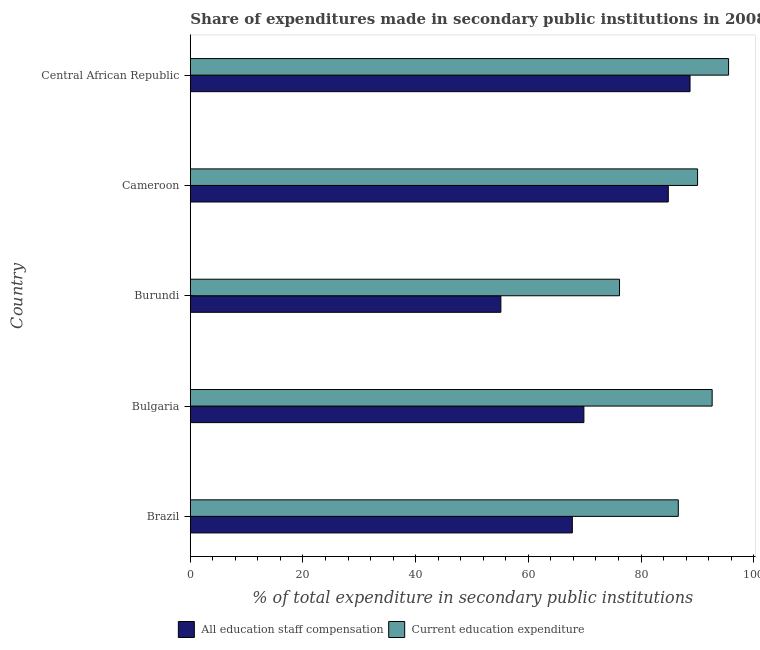How many groups of bars are there?
Your response must be concise. 5. Are the number of bars on each tick of the Y-axis equal?
Provide a succinct answer. Yes. What is the label of the 3rd group of bars from the top?
Your answer should be compact. Burundi. In how many cases, is the number of bars for a given country not equal to the number of legend labels?
Provide a short and direct response. 0. What is the expenditure in education in Cameroon?
Your response must be concise. 90.04. Across all countries, what is the maximum expenditure in staff compensation?
Provide a succinct answer. 88.7. Across all countries, what is the minimum expenditure in education?
Your answer should be very brief. 76.19. In which country was the expenditure in education maximum?
Make the answer very short. Central African Republic. In which country was the expenditure in education minimum?
Ensure brevity in your answer.  Burundi. What is the total expenditure in staff compensation in the graph?
Make the answer very short. 366.35. What is the difference between the expenditure in staff compensation in Brazil and that in Cameroon?
Your response must be concise. -17.03. What is the difference between the expenditure in education in Bulgaria and the expenditure in staff compensation in Central African Republic?
Provide a short and direct response. 3.93. What is the average expenditure in staff compensation per country?
Ensure brevity in your answer.  73.27. What is the difference between the expenditure in staff compensation and expenditure in education in Cameroon?
Offer a very short reply. -5.2. What is the ratio of the expenditure in education in Cameroon to that in Central African Republic?
Give a very brief answer. 0.94. Is the difference between the expenditure in education in Cameroon and Central African Republic greater than the difference between the expenditure in staff compensation in Cameroon and Central African Republic?
Keep it short and to the point. No. What is the difference between the highest and the second highest expenditure in staff compensation?
Keep it short and to the point. 3.86. What is the difference between the highest and the lowest expenditure in education?
Make the answer very short. 19.36. In how many countries, is the expenditure in education greater than the average expenditure in education taken over all countries?
Offer a very short reply. 3. What does the 1st bar from the top in Central African Republic represents?
Provide a short and direct response. Current education expenditure. What does the 1st bar from the bottom in Bulgaria represents?
Provide a succinct answer. All education staff compensation. How many bars are there?
Give a very brief answer. 10. Are all the bars in the graph horizontal?
Offer a terse response. Yes. How many countries are there in the graph?
Ensure brevity in your answer.  5. What is the difference between two consecutive major ticks on the X-axis?
Give a very brief answer. 20. Are the values on the major ticks of X-axis written in scientific E-notation?
Your answer should be very brief. No. Does the graph contain any zero values?
Ensure brevity in your answer.  No. How many legend labels are there?
Offer a terse response. 2. What is the title of the graph?
Ensure brevity in your answer.  Share of expenditures made in secondary public institutions in 2008. Does "Urban Population" appear as one of the legend labels in the graph?
Provide a short and direct response. No. What is the label or title of the X-axis?
Offer a very short reply. % of total expenditure in secondary public institutions. What is the label or title of the Y-axis?
Provide a short and direct response. Country. What is the % of total expenditure in secondary public institutions in All education staff compensation in Brazil?
Provide a succinct answer. 67.81. What is the % of total expenditure in secondary public institutions of Current education expenditure in Brazil?
Ensure brevity in your answer.  86.62. What is the % of total expenditure in secondary public institutions in All education staff compensation in Bulgaria?
Your response must be concise. 69.86. What is the % of total expenditure in secondary public institutions of Current education expenditure in Bulgaria?
Your answer should be very brief. 92.63. What is the % of total expenditure in secondary public institutions of All education staff compensation in Burundi?
Your response must be concise. 55.13. What is the % of total expenditure in secondary public institutions of Current education expenditure in Burundi?
Provide a short and direct response. 76.19. What is the % of total expenditure in secondary public institutions of All education staff compensation in Cameroon?
Your answer should be compact. 84.84. What is the % of total expenditure in secondary public institutions of Current education expenditure in Cameroon?
Make the answer very short. 90.04. What is the % of total expenditure in secondary public institutions in All education staff compensation in Central African Republic?
Make the answer very short. 88.7. What is the % of total expenditure in secondary public institutions in Current education expenditure in Central African Republic?
Offer a very short reply. 95.54. Across all countries, what is the maximum % of total expenditure in secondary public institutions of All education staff compensation?
Give a very brief answer. 88.7. Across all countries, what is the maximum % of total expenditure in secondary public institutions of Current education expenditure?
Your answer should be compact. 95.54. Across all countries, what is the minimum % of total expenditure in secondary public institutions of All education staff compensation?
Give a very brief answer. 55.13. Across all countries, what is the minimum % of total expenditure in secondary public institutions of Current education expenditure?
Make the answer very short. 76.19. What is the total % of total expenditure in secondary public institutions of All education staff compensation in the graph?
Ensure brevity in your answer.  366.35. What is the total % of total expenditure in secondary public institutions of Current education expenditure in the graph?
Offer a terse response. 441.03. What is the difference between the % of total expenditure in secondary public institutions in All education staff compensation in Brazil and that in Bulgaria?
Your response must be concise. -2.05. What is the difference between the % of total expenditure in secondary public institutions of Current education expenditure in Brazil and that in Bulgaria?
Provide a short and direct response. -6.01. What is the difference between the % of total expenditure in secondary public institutions in All education staff compensation in Brazil and that in Burundi?
Make the answer very short. 12.69. What is the difference between the % of total expenditure in secondary public institutions in Current education expenditure in Brazil and that in Burundi?
Provide a succinct answer. 10.43. What is the difference between the % of total expenditure in secondary public institutions in All education staff compensation in Brazil and that in Cameroon?
Provide a succinct answer. -17.03. What is the difference between the % of total expenditure in secondary public institutions in Current education expenditure in Brazil and that in Cameroon?
Keep it short and to the point. -3.42. What is the difference between the % of total expenditure in secondary public institutions in All education staff compensation in Brazil and that in Central African Republic?
Provide a succinct answer. -20.89. What is the difference between the % of total expenditure in secondary public institutions of Current education expenditure in Brazil and that in Central African Republic?
Keep it short and to the point. -8.93. What is the difference between the % of total expenditure in secondary public institutions in All education staff compensation in Bulgaria and that in Burundi?
Offer a terse response. 14.73. What is the difference between the % of total expenditure in secondary public institutions in Current education expenditure in Bulgaria and that in Burundi?
Provide a short and direct response. 16.44. What is the difference between the % of total expenditure in secondary public institutions in All education staff compensation in Bulgaria and that in Cameroon?
Your response must be concise. -14.98. What is the difference between the % of total expenditure in secondary public institutions in Current education expenditure in Bulgaria and that in Cameroon?
Your answer should be compact. 2.59. What is the difference between the % of total expenditure in secondary public institutions in All education staff compensation in Bulgaria and that in Central African Republic?
Provide a succinct answer. -18.84. What is the difference between the % of total expenditure in secondary public institutions of Current education expenditure in Bulgaria and that in Central African Republic?
Offer a terse response. -2.92. What is the difference between the % of total expenditure in secondary public institutions in All education staff compensation in Burundi and that in Cameroon?
Offer a terse response. -29.72. What is the difference between the % of total expenditure in secondary public institutions of Current education expenditure in Burundi and that in Cameroon?
Provide a short and direct response. -13.85. What is the difference between the % of total expenditure in secondary public institutions of All education staff compensation in Burundi and that in Central African Republic?
Give a very brief answer. -33.58. What is the difference between the % of total expenditure in secondary public institutions in Current education expenditure in Burundi and that in Central African Republic?
Provide a succinct answer. -19.36. What is the difference between the % of total expenditure in secondary public institutions of All education staff compensation in Cameroon and that in Central African Republic?
Ensure brevity in your answer.  -3.86. What is the difference between the % of total expenditure in secondary public institutions of Current education expenditure in Cameroon and that in Central African Republic?
Offer a very short reply. -5.5. What is the difference between the % of total expenditure in secondary public institutions of All education staff compensation in Brazil and the % of total expenditure in secondary public institutions of Current education expenditure in Bulgaria?
Offer a very short reply. -24.82. What is the difference between the % of total expenditure in secondary public institutions of All education staff compensation in Brazil and the % of total expenditure in secondary public institutions of Current education expenditure in Burundi?
Make the answer very short. -8.38. What is the difference between the % of total expenditure in secondary public institutions of All education staff compensation in Brazil and the % of total expenditure in secondary public institutions of Current education expenditure in Cameroon?
Provide a short and direct response. -22.23. What is the difference between the % of total expenditure in secondary public institutions in All education staff compensation in Brazil and the % of total expenditure in secondary public institutions in Current education expenditure in Central African Republic?
Your answer should be compact. -27.73. What is the difference between the % of total expenditure in secondary public institutions in All education staff compensation in Bulgaria and the % of total expenditure in secondary public institutions in Current education expenditure in Burundi?
Your answer should be very brief. -6.33. What is the difference between the % of total expenditure in secondary public institutions of All education staff compensation in Bulgaria and the % of total expenditure in secondary public institutions of Current education expenditure in Cameroon?
Give a very brief answer. -20.18. What is the difference between the % of total expenditure in secondary public institutions of All education staff compensation in Bulgaria and the % of total expenditure in secondary public institutions of Current education expenditure in Central African Republic?
Offer a terse response. -25.68. What is the difference between the % of total expenditure in secondary public institutions in All education staff compensation in Burundi and the % of total expenditure in secondary public institutions in Current education expenditure in Cameroon?
Your response must be concise. -34.91. What is the difference between the % of total expenditure in secondary public institutions of All education staff compensation in Burundi and the % of total expenditure in secondary public institutions of Current education expenditure in Central African Republic?
Provide a short and direct response. -40.42. What is the difference between the % of total expenditure in secondary public institutions in All education staff compensation in Cameroon and the % of total expenditure in secondary public institutions in Current education expenditure in Central African Republic?
Offer a terse response. -10.7. What is the average % of total expenditure in secondary public institutions in All education staff compensation per country?
Your answer should be very brief. 73.27. What is the average % of total expenditure in secondary public institutions of Current education expenditure per country?
Ensure brevity in your answer.  88.21. What is the difference between the % of total expenditure in secondary public institutions in All education staff compensation and % of total expenditure in secondary public institutions in Current education expenditure in Brazil?
Offer a terse response. -18.81. What is the difference between the % of total expenditure in secondary public institutions in All education staff compensation and % of total expenditure in secondary public institutions in Current education expenditure in Bulgaria?
Give a very brief answer. -22.77. What is the difference between the % of total expenditure in secondary public institutions in All education staff compensation and % of total expenditure in secondary public institutions in Current education expenditure in Burundi?
Your response must be concise. -21.06. What is the difference between the % of total expenditure in secondary public institutions in All education staff compensation and % of total expenditure in secondary public institutions in Current education expenditure in Cameroon?
Your answer should be very brief. -5.2. What is the difference between the % of total expenditure in secondary public institutions of All education staff compensation and % of total expenditure in secondary public institutions of Current education expenditure in Central African Republic?
Offer a terse response. -6.84. What is the ratio of the % of total expenditure in secondary public institutions of All education staff compensation in Brazil to that in Bulgaria?
Make the answer very short. 0.97. What is the ratio of the % of total expenditure in secondary public institutions of Current education expenditure in Brazil to that in Bulgaria?
Give a very brief answer. 0.94. What is the ratio of the % of total expenditure in secondary public institutions in All education staff compensation in Brazil to that in Burundi?
Keep it short and to the point. 1.23. What is the ratio of the % of total expenditure in secondary public institutions of Current education expenditure in Brazil to that in Burundi?
Keep it short and to the point. 1.14. What is the ratio of the % of total expenditure in secondary public institutions of All education staff compensation in Brazil to that in Cameroon?
Your answer should be compact. 0.8. What is the ratio of the % of total expenditure in secondary public institutions of Current education expenditure in Brazil to that in Cameroon?
Your response must be concise. 0.96. What is the ratio of the % of total expenditure in secondary public institutions of All education staff compensation in Brazil to that in Central African Republic?
Make the answer very short. 0.76. What is the ratio of the % of total expenditure in secondary public institutions of Current education expenditure in Brazil to that in Central African Republic?
Offer a terse response. 0.91. What is the ratio of the % of total expenditure in secondary public institutions in All education staff compensation in Bulgaria to that in Burundi?
Provide a succinct answer. 1.27. What is the ratio of the % of total expenditure in secondary public institutions in Current education expenditure in Bulgaria to that in Burundi?
Give a very brief answer. 1.22. What is the ratio of the % of total expenditure in secondary public institutions of All education staff compensation in Bulgaria to that in Cameroon?
Give a very brief answer. 0.82. What is the ratio of the % of total expenditure in secondary public institutions of Current education expenditure in Bulgaria to that in Cameroon?
Your response must be concise. 1.03. What is the ratio of the % of total expenditure in secondary public institutions in All education staff compensation in Bulgaria to that in Central African Republic?
Offer a terse response. 0.79. What is the ratio of the % of total expenditure in secondary public institutions of Current education expenditure in Bulgaria to that in Central African Republic?
Provide a short and direct response. 0.97. What is the ratio of the % of total expenditure in secondary public institutions in All education staff compensation in Burundi to that in Cameroon?
Your answer should be compact. 0.65. What is the ratio of the % of total expenditure in secondary public institutions of Current education expenditure in Burundi to that in Cameroon?
Provide a succinct answer. 0.85. What is the ratio of the % of total expenditure in secondary public institutions of All education staff compensation in Burundi to that in Central African Republic?
Your answer should be very brief. 0.62. What is the ratio of the % of total expenditure in secondary public institutions of Current education expenditure in Burundi to that in Central African Republic?
Keep it short and to the point. 0.8. What is the ratio of the % of total expenditure in secondary public institutions of All education staff compensation in Cameroon to that in Central African Republic?
Your response must be concise. 0.96. What is the ratio of the % of total expenditure in secondary public institutions in Current education expenditure in Cameroon to that in Central African Republic?
Keep it short and to the point. 0.94. What is the difference between the highest and the second highest % of total expenditure in secondary public institutions in All education staff compensation?
Offer a terse response. 3.86. What is the difference between the highest and the second highest % of total expenditure in secondary public institutions of Current education expenditure?
Your answer should be very brief. 2.92. What is the difference between the highest and the lowest % of total expenditure in secondary public institutions in All education staff compensation?
Your answer should be compact. 33.58. What is the difference between the highest and the lowest % of total expenditure in secondary public institutions in Current education expenditure?
Your answer should be very brief. 19.36. 